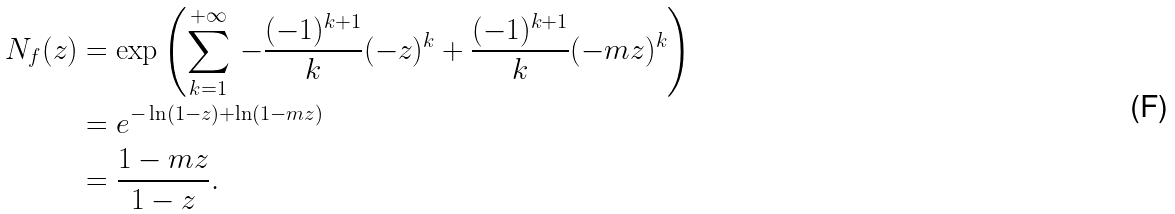<formula> <loc_0><loc_0><loc_500><loc_500>N _ { f } ( z ) & = \exp \left ( \sum _ { k = 1 } ^ { + \infty } \, - \frac { ( - 1 ) ^ { k + 1 } } { k } ( - z ) ^ { k } + \frac { ( - 1 ) ^ { k + 1 } } { k } ( - m z ) ^ { k } \right ) \\ & = e ^ { - \ln ( 1 - z ) + \ln ( 1 - m z ) } \\ & = \frac { 1 - m z } { 1 - z } .</formula> 